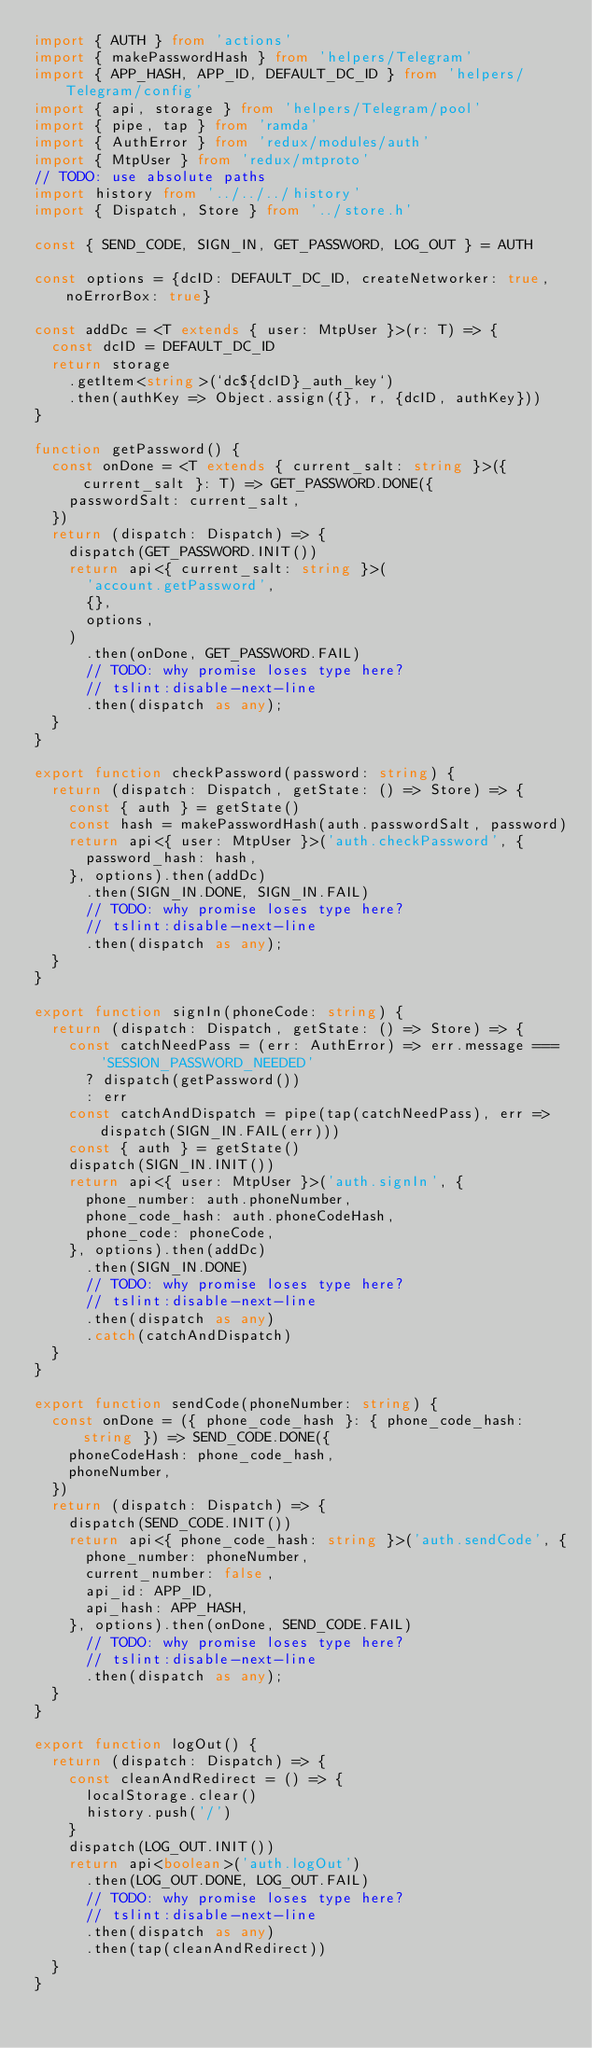Convert code to text. <code><loc_0><loc_0><loc_500><loc_500><_TypeScript_>import { AUTH } from 'actions'
import { makePasswordHash } from 'helpers/Telegram'
import { APP_HASH, APP_ID, DEFAULT_DC_ID } from 'helpers/Telegram/config'
import { api, storage } from 'helpers/Telegram/pool'
import { pipe, tap } from 'ramda'
import { AuthError } from 'redux/modules/auth'
import { MtpUser } from 'redux/mtproto'
// TODO: use absolute paths
import history from '../../../history'
import { Dispatch, Store } from '../store.h'

const { SEND_CODE, SIGN_IN, GET_PASSWORD, LOG_OUT } = AUTH

const options = {dcID: DEFAULT_DC_ID, createNetworker: true, noErrorBox: true}

const addDc = <T extends { user: MtpUser }>(r: T) => {
  const dcID = DEFAULT_DC_ID
  return storage
    .getItem<string>(`dc${dcID}_auth_key`)
    .then(authKey => Object.assign({}, r, {dcID, authKey}))
}

function getPassword() {
  const onDone = <T extends { current_salt: string }>({ current_salt }: T) => GET_PASSWORD.DONE({
    passwordSalt: current_salt,
  })
  return (dispatch: Dispatch) => {
    dispatch(GET_PASSWORD.INIT())
    return api<{ current_salt: string }>(
      'account.getPassword',
      {},
      options,
    )
      .then(onDone, GET_PASSWORD.FAIL)
      // TODO: why promise loses type here?
      // tslint:disable-next-line
      .then(dispatch as any);
  }
}

export function checkPassword(password: string) {
  return (dispatch: Dispatch, getState: () => Store) => {
    const { auth } = getState()
    const hash = makePasswordHash(auth.passwordSalt, password)
    return api<{ user: MtpUser }>('auth.checkPassword', {
      password_hash: hash,
    }, options).then(addDc)
      .then(SIGN_IN.DONE, SIGN_IN.FAIL)
      // TODO: why promise loses type here?
      // tslint:disable-next-line
      .then(dispatch as any);
  }
}

export function signIn(phoneCode: string) {
  return (dispatch: Dispatch, getState: () => Store) => {
    const catchNeedPass = (err: AuthError) => err.message === 'SESSION_PASSWORD_NEEDED'
      ? dispatch(getPassword())
      : err
    const catchAndDispatch = pipe(tap(catchNeedPass), err => dispatch(SIGN_IN.FAIL(err)))
    const { auth } = getState()
    dispatch(SIGN_IN.INIT())
    return api<{ user: MtpUser }>('auth.signIn', {
      phone_number: auth.phoneNumber,
      phone_code_hash: auth.phoneCodeHash,
      phone_code: phoneCode,
    }, options).then(addDc)
      .then(SIGN_IN.DONE)
      // TODO: why promise loses type here?
      // tslint:disable-next-line
      .then(dispatch as any)
      .catch(catchAndDispatch)
  }
}

export function sendCode(phoneNumber: string) {
  const onDone = ({ phone_code_hash }: { phone_code_hash: string }) => SEND_CODE.DONE({
    phoneCodeHash: phone_code_hash,
    phoneNumber,
  })
  return (dispatch: Dispatch) => {
    dispatch(SEND_CODE.INIT())
    return api<{ phone_code_hash: string }>('auth.sendCode', {
      phone_number: phoneNumber,
      current_number: false,
      api_id: APP_ID,
      api_hash: APP_HASH,
    }, options).then(onDone, SEND_CODE.FAIL)
      // TODO: why promise loses type here?
      // tslint:disable-next-line
      .then(dispatch as any);
  }
}

export function logOut() {
  return (dispatch: Dispatch) => {
    const cleanAndRedirect = () => {
      localStorage.clear()
      history.push('/')
    }
    dispatch(LOG_OUT.INIT())
    return api<boolean>('auth.logOut')
      .then(LOG_OUT.DONE, LOG_OUT.FAIL)
      // TODO: why promise loses type here?
      // tslint:disable-next-line
      .then(dispatch as any)
      .then(tap(cleanAndRedirect))
  }
}
</code> 